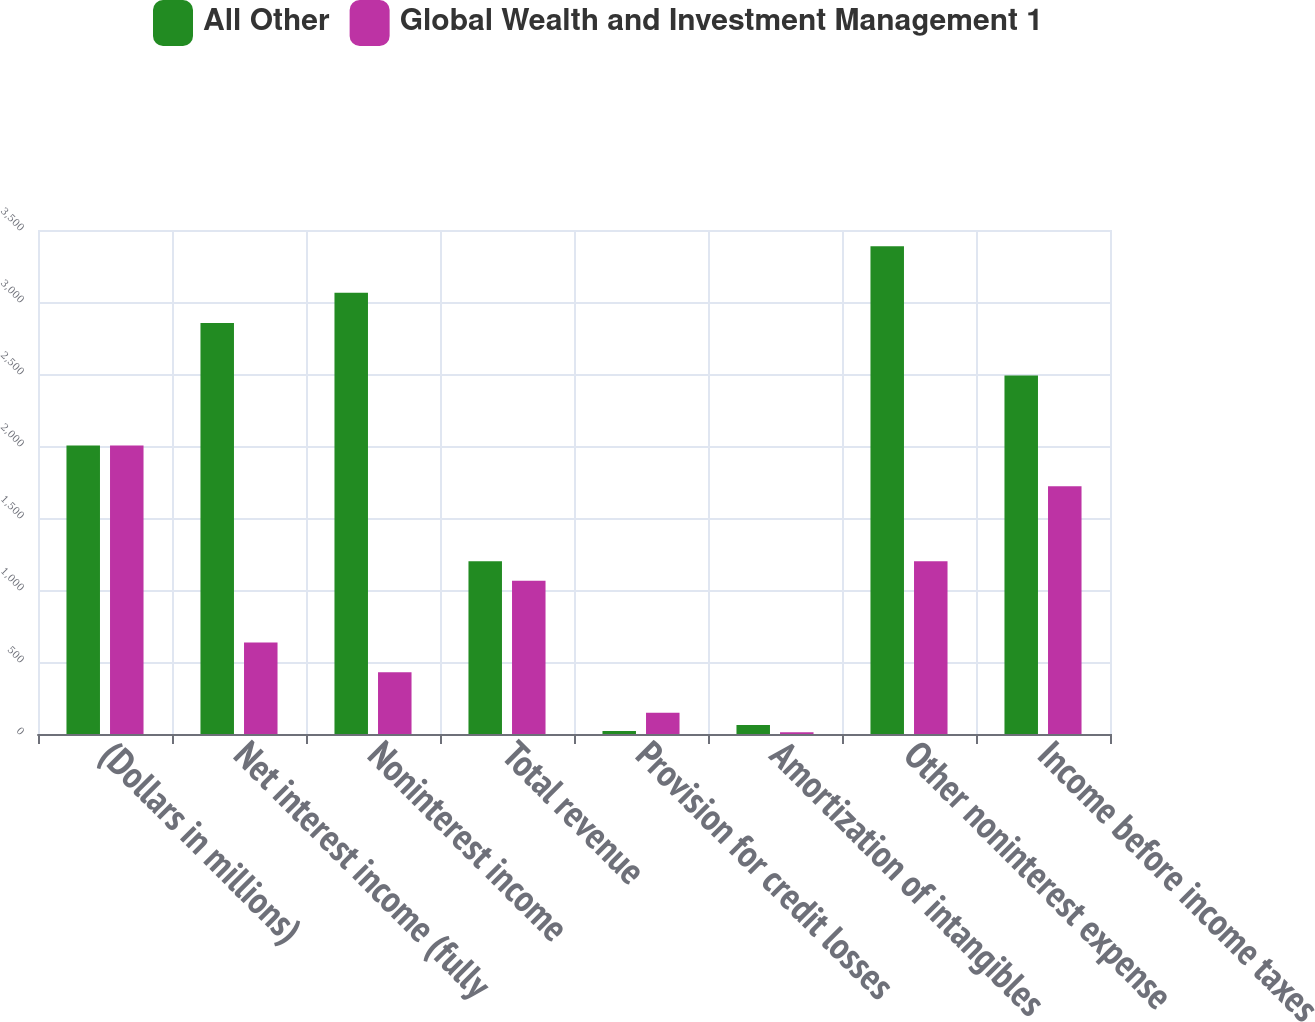<chart> <loc_0><loc_0><loc_500><loc_500><stacked_bar_chart><ecel><fcel>(Dollars in millions)<fcel>Net interest income (fully<fcel>Noninterest income<fcel>Total revenue<fcel>Provision for credit losses<fcel>Amortization of intangibles<fcel>Other noninterest expense<fcel>Income before income taxes<nl><fcel>All Other<fcel>2004<fcel>2854<fcel>3064<fcel>1199<fcel>20<fcel>62<fcel>3387<fcel>2489<nl><fcel>Global Wealth and Investment Management 1<fcel>2004<fcel>636<fcel>428<fcel>1064<fcel>148<fcel>13<fcel>1199<fcel>1720<nl></chart> 